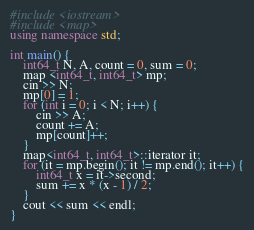<code> <loc_0><loc_0><loc_500><loc_500><_C++_>#include <iostream>
#include <map>
using namespace std;

int main() {
	int64_t N, A, count = 0, sum = 0;
	map <int64_t, int64_t> mp;
	cin >> N;
	mp[0] = 1;
	for (int i = 0; i < N; i++) {
		cin >> A;
		count += A;
		mp[count]++;
	}
	map<int64_t, int64_t>::iterator it;
	for (it = mp.begin(); it != mp.end(); it++) {
		int64_t x = it->second;
		sum += x * (x - 1) / 2;
	}
	cout << sum << endl;
}</code> 